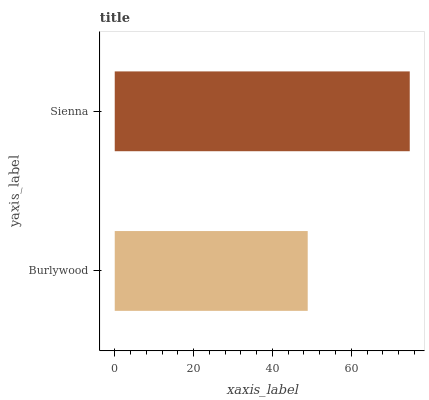Is Burlywood the minimum?
Answer yes or no. Yes. Is Sienna the maximum?
Answer yes or no. Yes. Is Sienna the minimum?
Answer yes or no. No. Is Sienna greater than Burlywood?
Answer yes or no. Yes. Is Burlywood less than Sienna?
Answer yes or no. Yes. Is Burlywood greater than Sienna?
Answer yes or no. No. Is Sienna less than Burlywood?
Answer yes or no. No. Is Sienna the high median?
Answer yes or no. Yes. Is Burlywood the low median?
Answer yes or no. Yes. Is Burlywood the high median?
Answer yes or no. No. Is Sienna the low median?
Answer yes or no. No. 